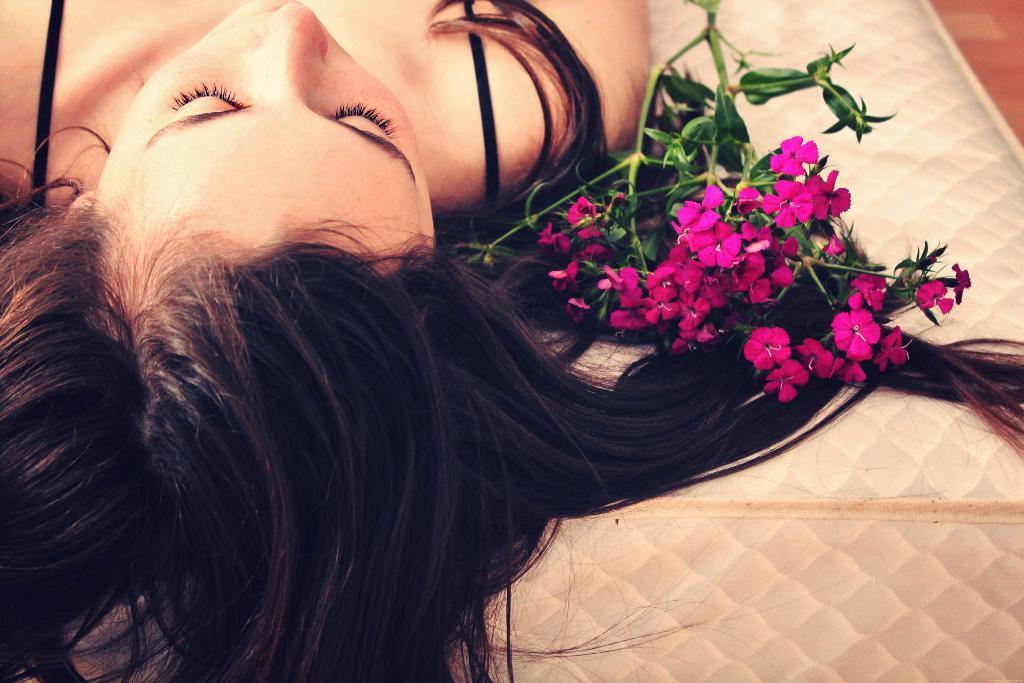Please provide a concise description of this image. In this image I can see a woman is laying on a bed. Beside her there is a stem along with the flowers and leaves. 